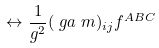Convert formula to latex. <formula><loc_0><loc_0><loc_500><loc_500>& \leftrightarrow \frac { 1 } { g ^ { 2 } } ( \ g a ^ { \ } m ) _ { i j } f ^ { A B C }</formula> 